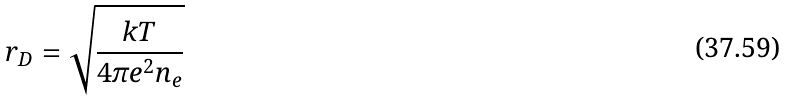<formula> <loc_0><loc_0><loc_500><loc_500>r _ { D } = \sqrt { \frac { k T } { 4 \pi e ^ { 2 } n _ { e } } }</formula> 